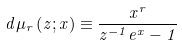Convert formula to latex. <formula><loc_0><loc_0><loc_500><loc_500>d \mu _ { r } \left ( z ; x \right ) \equiv \frac { x ^ { r } } { z ^ { - 1 } e ^ { x } - 1 }</formula> 